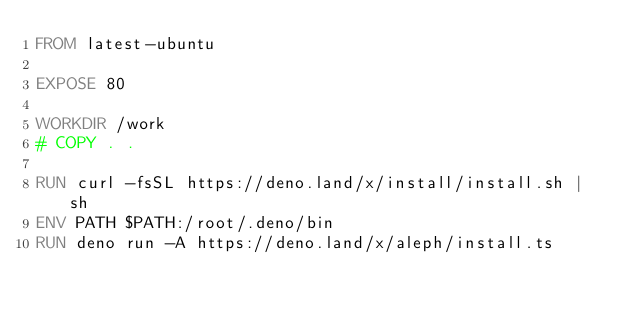<code> <loc_0><loc_0><loc_500><loc_500><_Dockerfile_>FROM latest-ubuntu

EXPOSE 80

WORKDIR /work
# COPY . .

RUN curl -fsSL https://deno.land/x/install/install.sh | sh
ENV PATH $PATH:/root/.deno/bin
RUN deno run -A https://deno.land/x/aleph/install.ts
</code> 